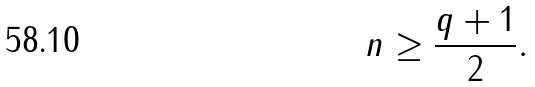<formula> <loc_0><loc_0><loc_500><loc_500>n \geq { \frac { q + 1 } { 2 } } .</formula> 